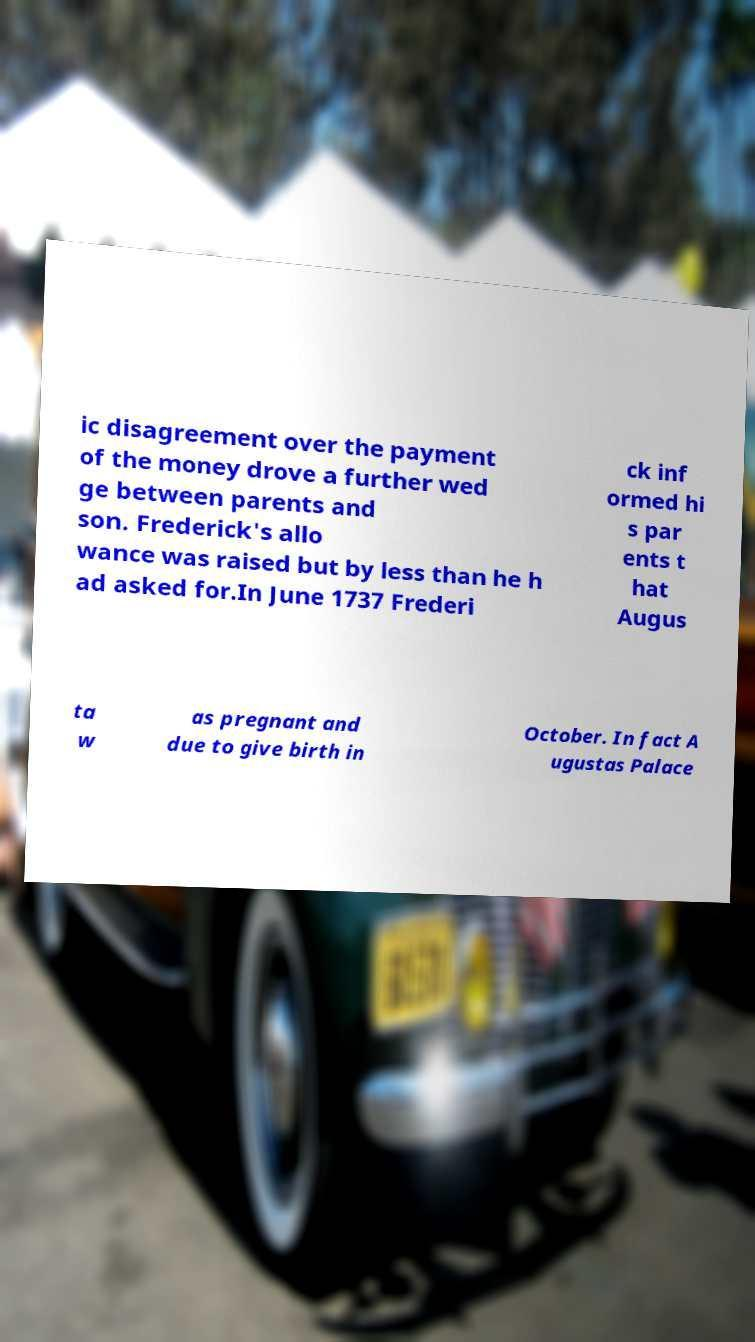Please read and relay the text visible in this image. What does it say? ic disagreement over the payment of the money drove a further wed ge between parents and son. Frederick's allo wance was raised but by less than he h ad asked for.In June 1737 Frederi ck inf ormed hi s par ents t hat Augus ta w as pregnant and due to give birth in October. In fact A ugustas Palace 